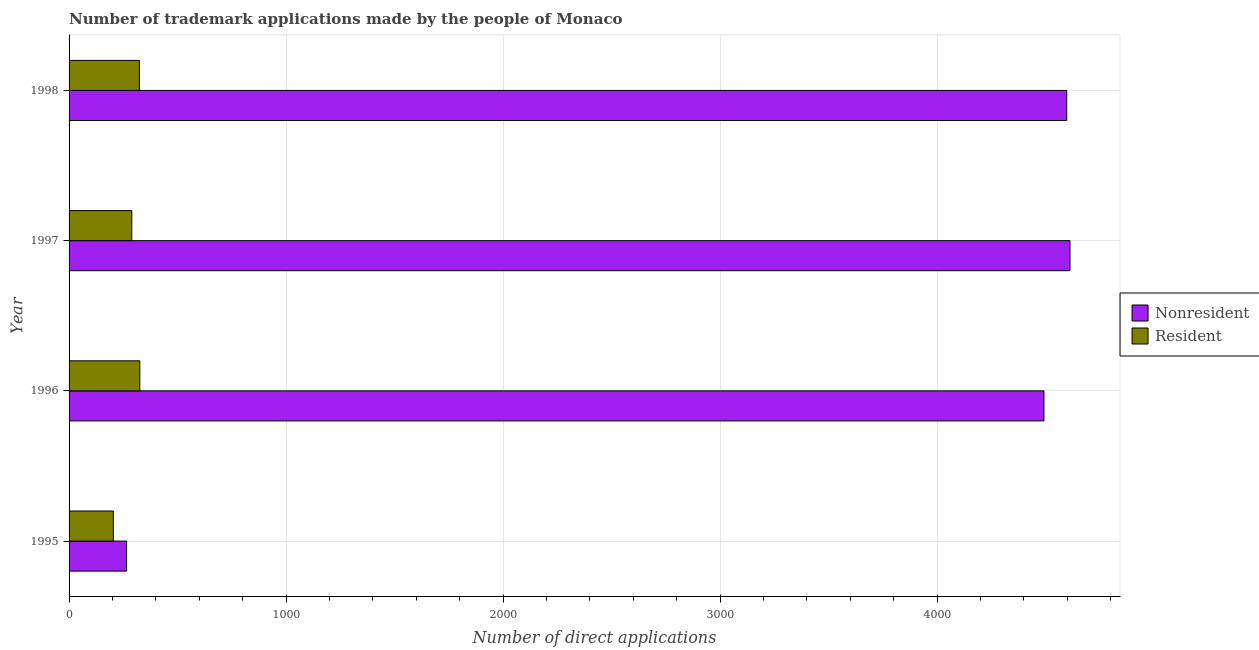How many bars are there on the 3rd tick from the bottom?
Offer a very short reply. 2. What is the number of trademark applications made by non residents in 1996?
Keep it short and to the point. 4492. Across all years, what is the maximum number of trademark applications made by non residents?
Your answer should be very brief. 4612. Across all years, what is the minimum number of trademark applications made by non residents?
Your answer should be very brief. 265. In which year was the number of trademark applications made by non residents maximum?
Your answer should be compact. 1997. In which year was the number of trademark applications made by non residents minimum?
Provide a short and direct response. 1995. What is the total number of trademark applications made by non residents in the graph?
Make the answer very short. 1.40e+04. What is the difference between the number of trademark applications made by residents in 1995 and that in 1997?
Ensure brevity in your answer.  -85. What is the difference between the number of trademark applications made by non residents in 1995 and the number of trademark applications made by residents in 1998?
Make the answer very short. -59. What is the average number of trademark applications made by non residents per year?
Give a very brief answer. 3491.5. In the year 1995, what is the difference between the number of trademark applications made by non residents and number of trademark applications made by residents?
Offer a terse response. 61. In how many years, is the number of trademark applications made by non residents greater than 4200 ?
Your response must be concise. 3. What is the ratio of the number of trademark applications made by residents in 1995 to that in 1997?
Ensure brevity in your answer.  0.71. What is the difference between the highest and the lowest number of trademark applications made by non residents?
Provide a short and direct response. 4347. In how many years, is the number of trademark applications made by residents greater than the average number of trademark applications made by residents taken over all years?
Your response must be concise. 3. Is the sum of the number of trademark applications made by non residents in 1995 and 1997 greater than the maximum number of trademark applications made by residents across all years?
Provide a succinct answer. Yes. What does the 2nd bar from the top in 1995 represents?
Offer a terse response. Nonresident. What does the 2nd bar from the bottom in 1997 represents?
Your response must be concise. Resident. Are all the bars in the graph horizontal?
Ensure brevity in your answer.  Yes. Are the values on the major ticks of X-axis written in scientific E-notation?
Your answer should be very brief. No. Does the graph contain any zero values?
Provide a succinct answer. No. What is the title of the graph?
Make the answer very short. Number of trademark applications made by the people of Monaco. Does "IMF concessional" appear as one of the legend labels in the graph?
Give a very brief answer. No. What is the label or title of the X-axis?
Keep it short and to the point. Number of direct applications. What is the Number of direct applications of Nonresident in 1995?
Provide a succinct answer. 265. What is the Number of direct applications of Resident in 1995?
Provide a succinct answer. 204. What is the Number of direct applications in Nonresident in 1996?
Your response must be concise. 4492. What is the Number of direct applications of Resident in 1996?
Make the answer very short. 326. What is the Number of direct applications in Nonresident in 1997?
Keep it short and to the point. 4612. What is the Number of direct applications of Resident in 1997?
Ensure brevity in your answer.  289. What is the Number of direct applications in Nonresident in 1998?
Ensure brevity in your answer.  4597. What is the Number of direct applications in Resident in 1998?
Offer a very short reply. 324. Across all years, what is the maximum Number of direct applications of Nonresident?
Your response must be concise. 4612. Across all years, what is the maximum Number of direct applications in Resident?
Ensure brevity in your answer.  326. Across all years, what is the minimum Number of direct applications in Nonresident?
Give a very brief answer. 265. Across all years, what is the minimum Number of direct applications in Resident?
Provide a succinct answer. 204. What is the total Number of direct applications in Nonresident in the graph?
Keep it short and to the point. 1.40e+04. What is the total Number of direct applications of Resident in the graph?
Your answer should be compact. 1143. What is the difference between the Number of direct applications of Nonresident in 1995 and that in 1996?
Give a very brief answer. -4227. What is the difference between the Number of direct applications of Resident in 1995 and that in 1996?
Give a very brief answer. -122. What is the difference between the Number of direct applications in Nonresident in 1995 and that in 1997?
Provide a succinct answer. -4347. What is the difference between the Number of direct applications in Resident in 1995 and that in 1997?
Give a very brief answer. -85. What is the difference between the Number of direct applications of Nonresident in 1995 and that in 1998?
Make the answer very short. -4332. What is the difference between the Number of direct applications in Resident in 1995 and that in 1998?
Your answer should be compact. -120. What is the difference between the Number of direct applications of Nonresident in 1996 and that in 1997?
Your response must be concise. -120. What is the difference between the Number of direct applications of Nonresident in 1996 and that in 1998?
Your answer should be very brief. -105. What is the difference between the Number of direct applications of Resident in 1996 and that in 1998?
Your response must be concise. 2. What is the difference between the Number of direct applications of Nonresident in 1997 and that in 1998?
Make the answer very short. 15. What is the difference between the Number of direct applications in Resident in 1997 and that in 1998?
Give a very brief answer. -35. What is the difference between the Number of direct applications in Nonresident in 1995 and the Number of direct applications in Resident in 1996?
Your response must be concise. -61. What is the difference between the Number of direct applications in Nonresident in 1995 and the Number of direct applications in Resident in 1997?
Keep it short and to the point. -24. What is the difference between the Number of direct applications of Nonresident in 1995 and the Number of direct applications of Resident in 1998?
Offer a terse response. -59. What is the difference between the Number of direct applications in Nonresident in 1996 and the Number of direct applications in Resident in 1997?
Make the answer very short. 4203. What is the difference between the Number of direct applications in Nonresident in 1996 and the Number of direct applications in Resident in 1998?
Your answer should be compact. 4168. What is the difference between the Number of direct applications of Nonresident in 1997 and the Number of direct applications of Resident in 1998?
Offer a very short reply. 4288. What is the average Number of direct applications of Nonresident per year?
Your answer should be compact. 3491.5. What is the average Number of direct applications of Resident per year?
Offer a terse response. 285.75. In the year 1995, what is the difference between the Number of direct applications in Nonresident and Number of direct applications in Resident?
Your response must be concise. 61. In the year 1996, what is the difference between the Number of direct applications of Nonresident and Number of direct applications of Resident?
Your answer should be compact. 4166. In the year 1997, what is the difference between the Number of direct applications of Nonresident and Number of direct applications of Resident?
Offer a terse response. 4323. In the year 1998, what is the difference between the Number of direct applications of Nonresident and Number of direct applications of Resident?
Your answer should be very brief. 4273. What is the ratio of the Number of direct applications in Nonresident in 1995 to that in 1996?
Make the answer very short. 0.06. What is the ratio of the Number of direct applications of Resident in 1995 to that in 1996?
Ensure brevity in your answer.  0.63. What is the ratio of the Number of direct applications of Nonresident in 1995 to that in 1997?
Offer a very short reply. 0.06. What is the ratio of the Number of direct applications in Resident in 1995 to that in 1997?
Your response must be concise. 0.71. What is the ratio of the Number of direct applications of Nonresident in 1995 to that in 1998?
Your answer should be very brief. 0.06. What is the ratio of the Number of direct applications in Resident in 1995 to that in 1998?
Keep it short and to the point. 0.63. What is the ratio of the Number of direct applications of Resident in 1996 to that in 1997?
Offer a terse response. 1.13. What is the ratio of the Number of direct applications of Nonresident in 1996 to that in 1998?
Offer a terse response. 0.98. What is the ratio of the Number of direct applications of Resident in 1997 to that in 1998?
Give a very brief answer. 0.89. What is the difference between the highest and the second highest Number of direct applications in Resident?
Ensure brevity in your answer.  2. What is the difference between the highest and the lowest Number of direct applications in Nonresident?
Offer a very short reply. 4347. What is the difference between the highest and the lowest Number of direct applications of Resident?
Keep it short and to the point. 122. 